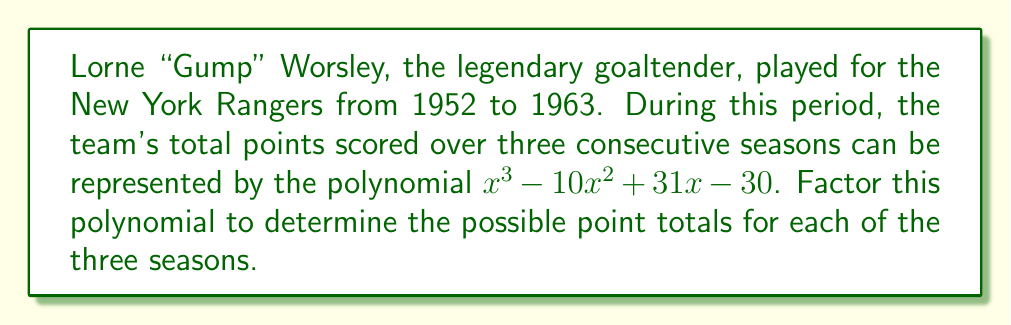Give your solution to this math problem. To factor this cubic polynomial, we'll follow these steps:

1) First, let's check if there are any rational roots using the rational root theorem. The possible rational roots are the factors of the constant term (30): ±1, ±2, ±3, ±5, ±6, ±10, ±15, ±30.

2) Testing these values, we find that x = 2 is a root of the polynomial.

3) We can now use polynomial long division to divide the original polynomial by (x - 2):

   $\frac{x^3 - 10x^2 + 31x - 30}{x - 2} = x^2 - 8x + 15$

4) The resulting quadratic polynomial $x^2 - 8x + 15$ can be factored further:

   $x^2 - 8x + 15 = (x - 3)(x - 5)$

5) Therefore, the complete factorization of the original polynomial is:

   $x^3 - 10x^2 + 31x - 30 = (x - 2)(x - 3)(x - 5)$

This factorization reveals that the possible point totals for each of the three seasons were 2, 3, and 5.
Answer: $(x - 2)(x - 3)(x - 5)$ 